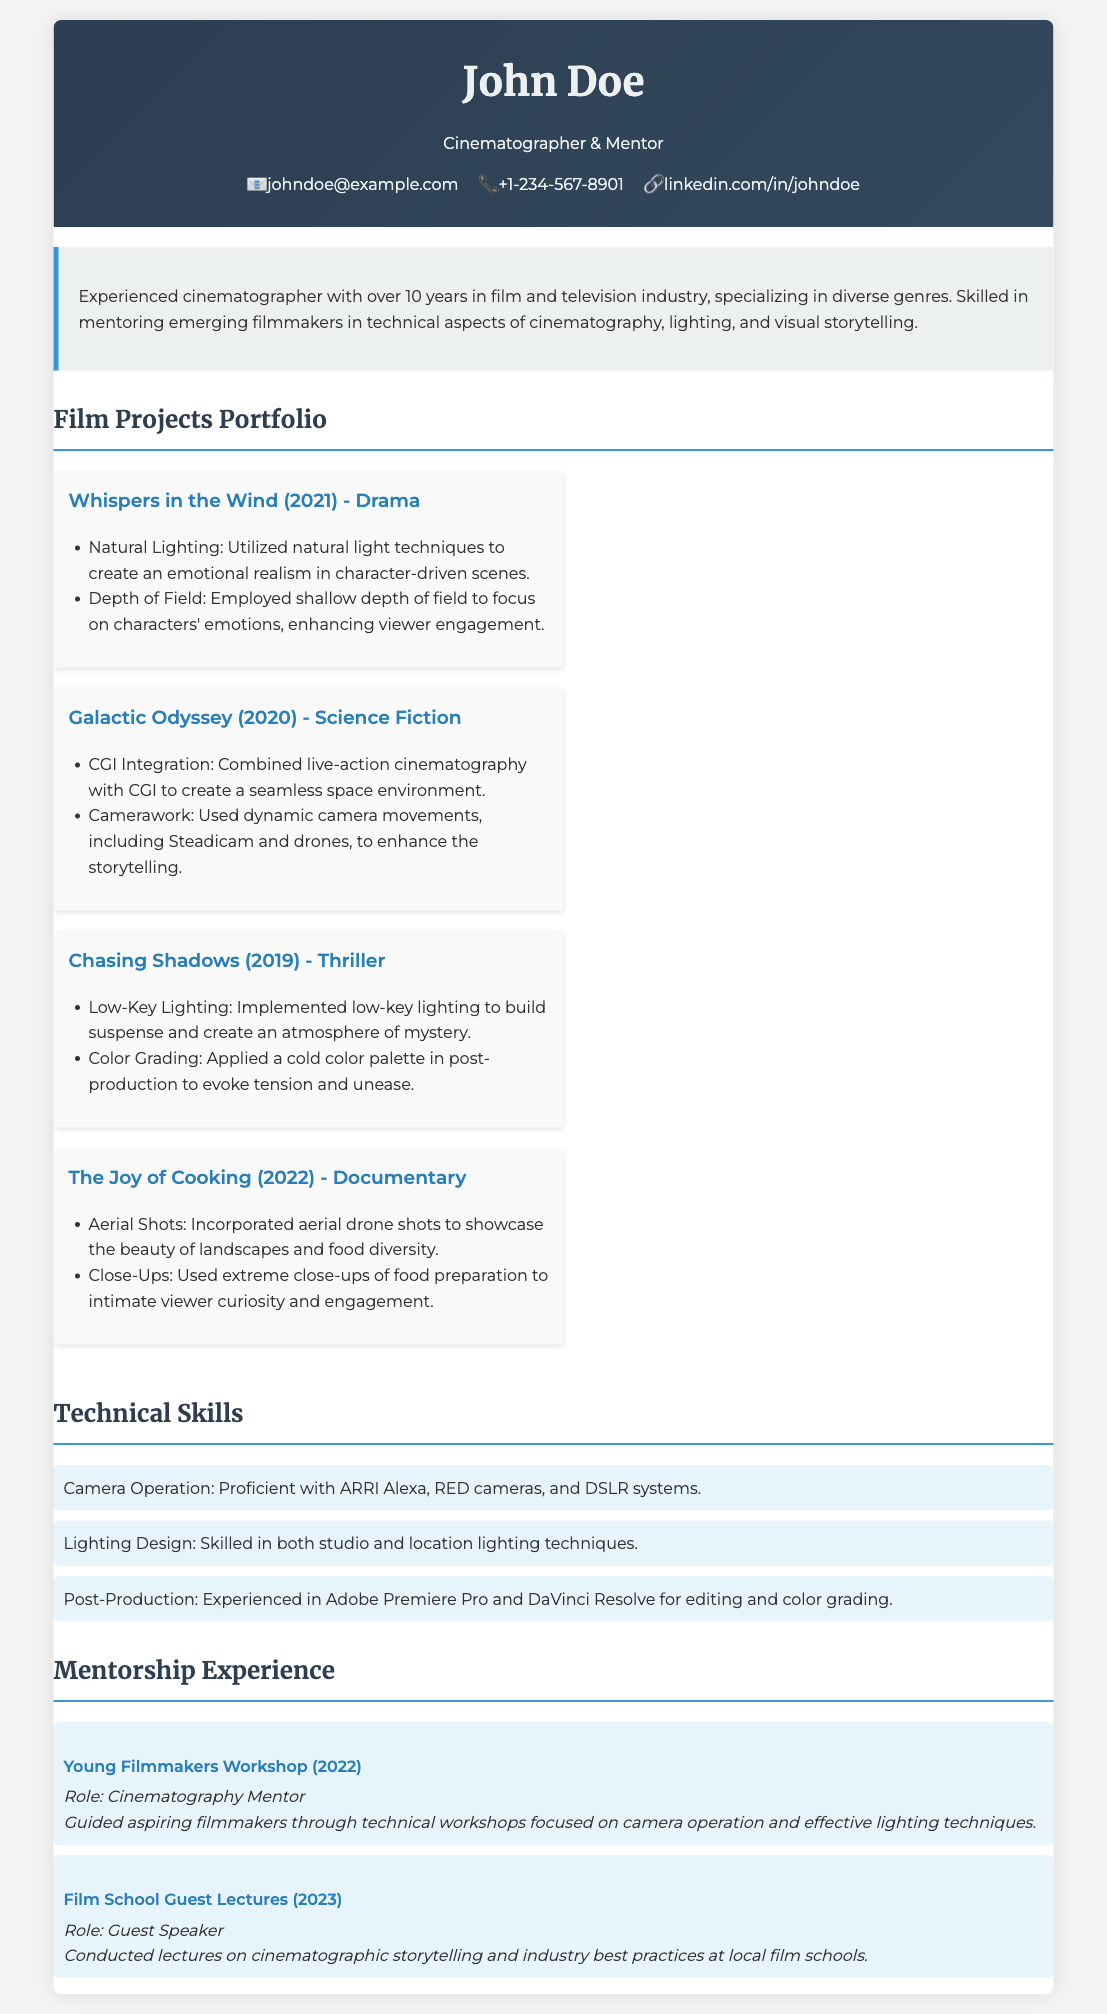what is the name of the cinematographer? The cinematographer's name is prominently displayed at the top of the document.
Answer: John Doe how many years of experience does the cinematographer have? The summary section of the document states the years of experience of the cinematographer.
Answer: over 10 years which film is categorized as a Documentary? In the Film Projects Portfolio section, the category for each film is listed; this one is specified as a Documentary.
Answer: The Joy of Cooking what cinematographic technique was used in "Whispers in the Wind"? The document lists specific techniques utilized for each film project; one is highlighted for "Whispers in the Wind".
Answer: Natural Lighting what type of lighting technique was implemented in "Chasing Shadows"? The film details include the specific lighting technique used in "Chasing Shadows".
Answer: Low-Key Lighting how many projects are listed in the Film Projects Portfolio? By counting the entries in the Film Projects Portfolio section, the total number of projects can be determined.
Answer: 4 who mentored at the Young Filmmakers Workshop? The Mentorship Experience section indicates the role and contributions of John Doe at this specific workshop.
Answer: John Doe what is one of the post-production software mentioned? The Technical Skills section lists the software tools that the cinematographer is experienced with, including one for post-production.
Answer: Adobe Premiere Pro what type of camera operation is John proficient with? The Technical Skills section specifies the camera systems John is proficient in.
Answer: ARRI Alexa, RED cameras, and DSLR systems 